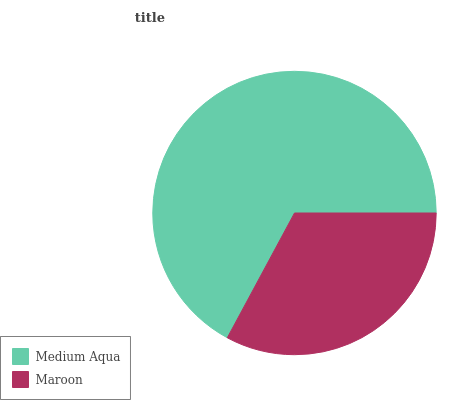Is Maroon the minimum?
Answer yes or no. Yes. Is Medium Aqua the maximum?
Answer yes or no. Yes. Is Maroon the maximum?
Answer yes or no. No. Is Medium Aqua greater than Maroon?
Answer yes or no. Yes. Is Maroon less than Medium Aqua?
Answer yes or no. Yes. Is Maroon greater than Medium Aqua?
Answer yes or no. No. Is Medium Aqua less than Maroon?
Answer yes or no. No. Is Medium Aqua the high median?
Answer yes or no. Yes. Is Maroon the low median?
Answer yes or no. Yes. Is Maroon the high median?
Answer yes or no. No. Is Medium Aqua the low median?
Answer yes or no. No. 